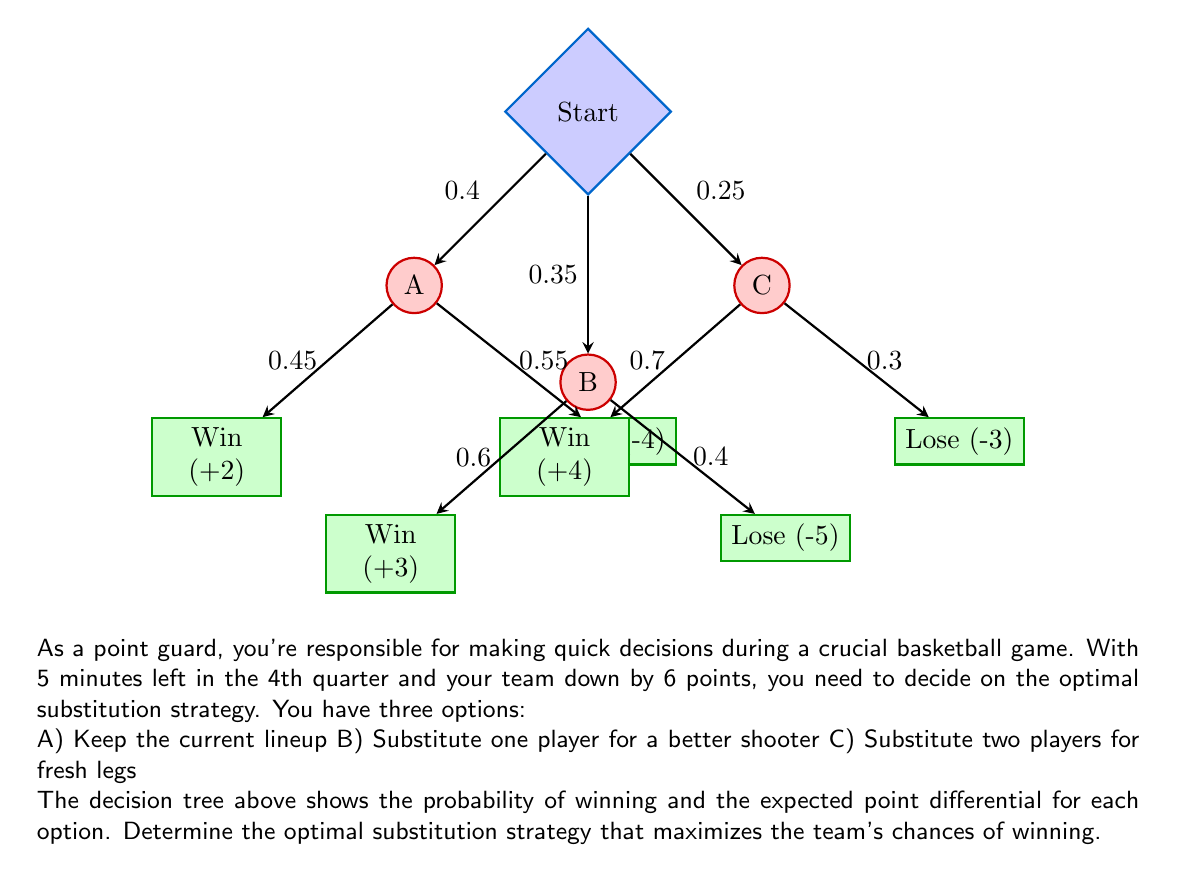Show me your answer to this math problem. To determine the optimal substitution strategy, we need to calculate the expected value (EV) for each option using the given probabilities and point differentials. The option with the highest EV will be the optimal strategy.

Step 1: Calculate EV for option A (Keep current lineup)
$$EV_A = 0.45 \cdot (+2) + 0.55 \cdot (-4) = 0.9 - 2.2 = -1.3$$

Step 2: Calculate EV for option B (Substitute one player)
$$EV_B = 0.6 \cdot (+3) + 0.4 \cdot (-5) = 1.8 - 2 = -0.2$$

Step 3: Calculate EV for option C (Substitute two players)
$$EV_C = 0.7 \cdot (+4) + 0.3 \cdot (-3) = 2.8 - 0.9 = 1.9$$

Step 4: Compare the expected values
$$EV_A = -1.3$$
$$EV_B = -0.2$$
$$EV_C = 1.9$$

Step 5: Calculate the probability of winning for each option
Option A: 0.45 (45%)
Option B: 0.6 (60%)
Option C: 0.7 (70%)

The optimal strategy is the one with the highest expected value and the highest probability of winning, which is option C (Substitute two players for fresh legs).
Answer: Option C: Substitute two players for fresh legs 